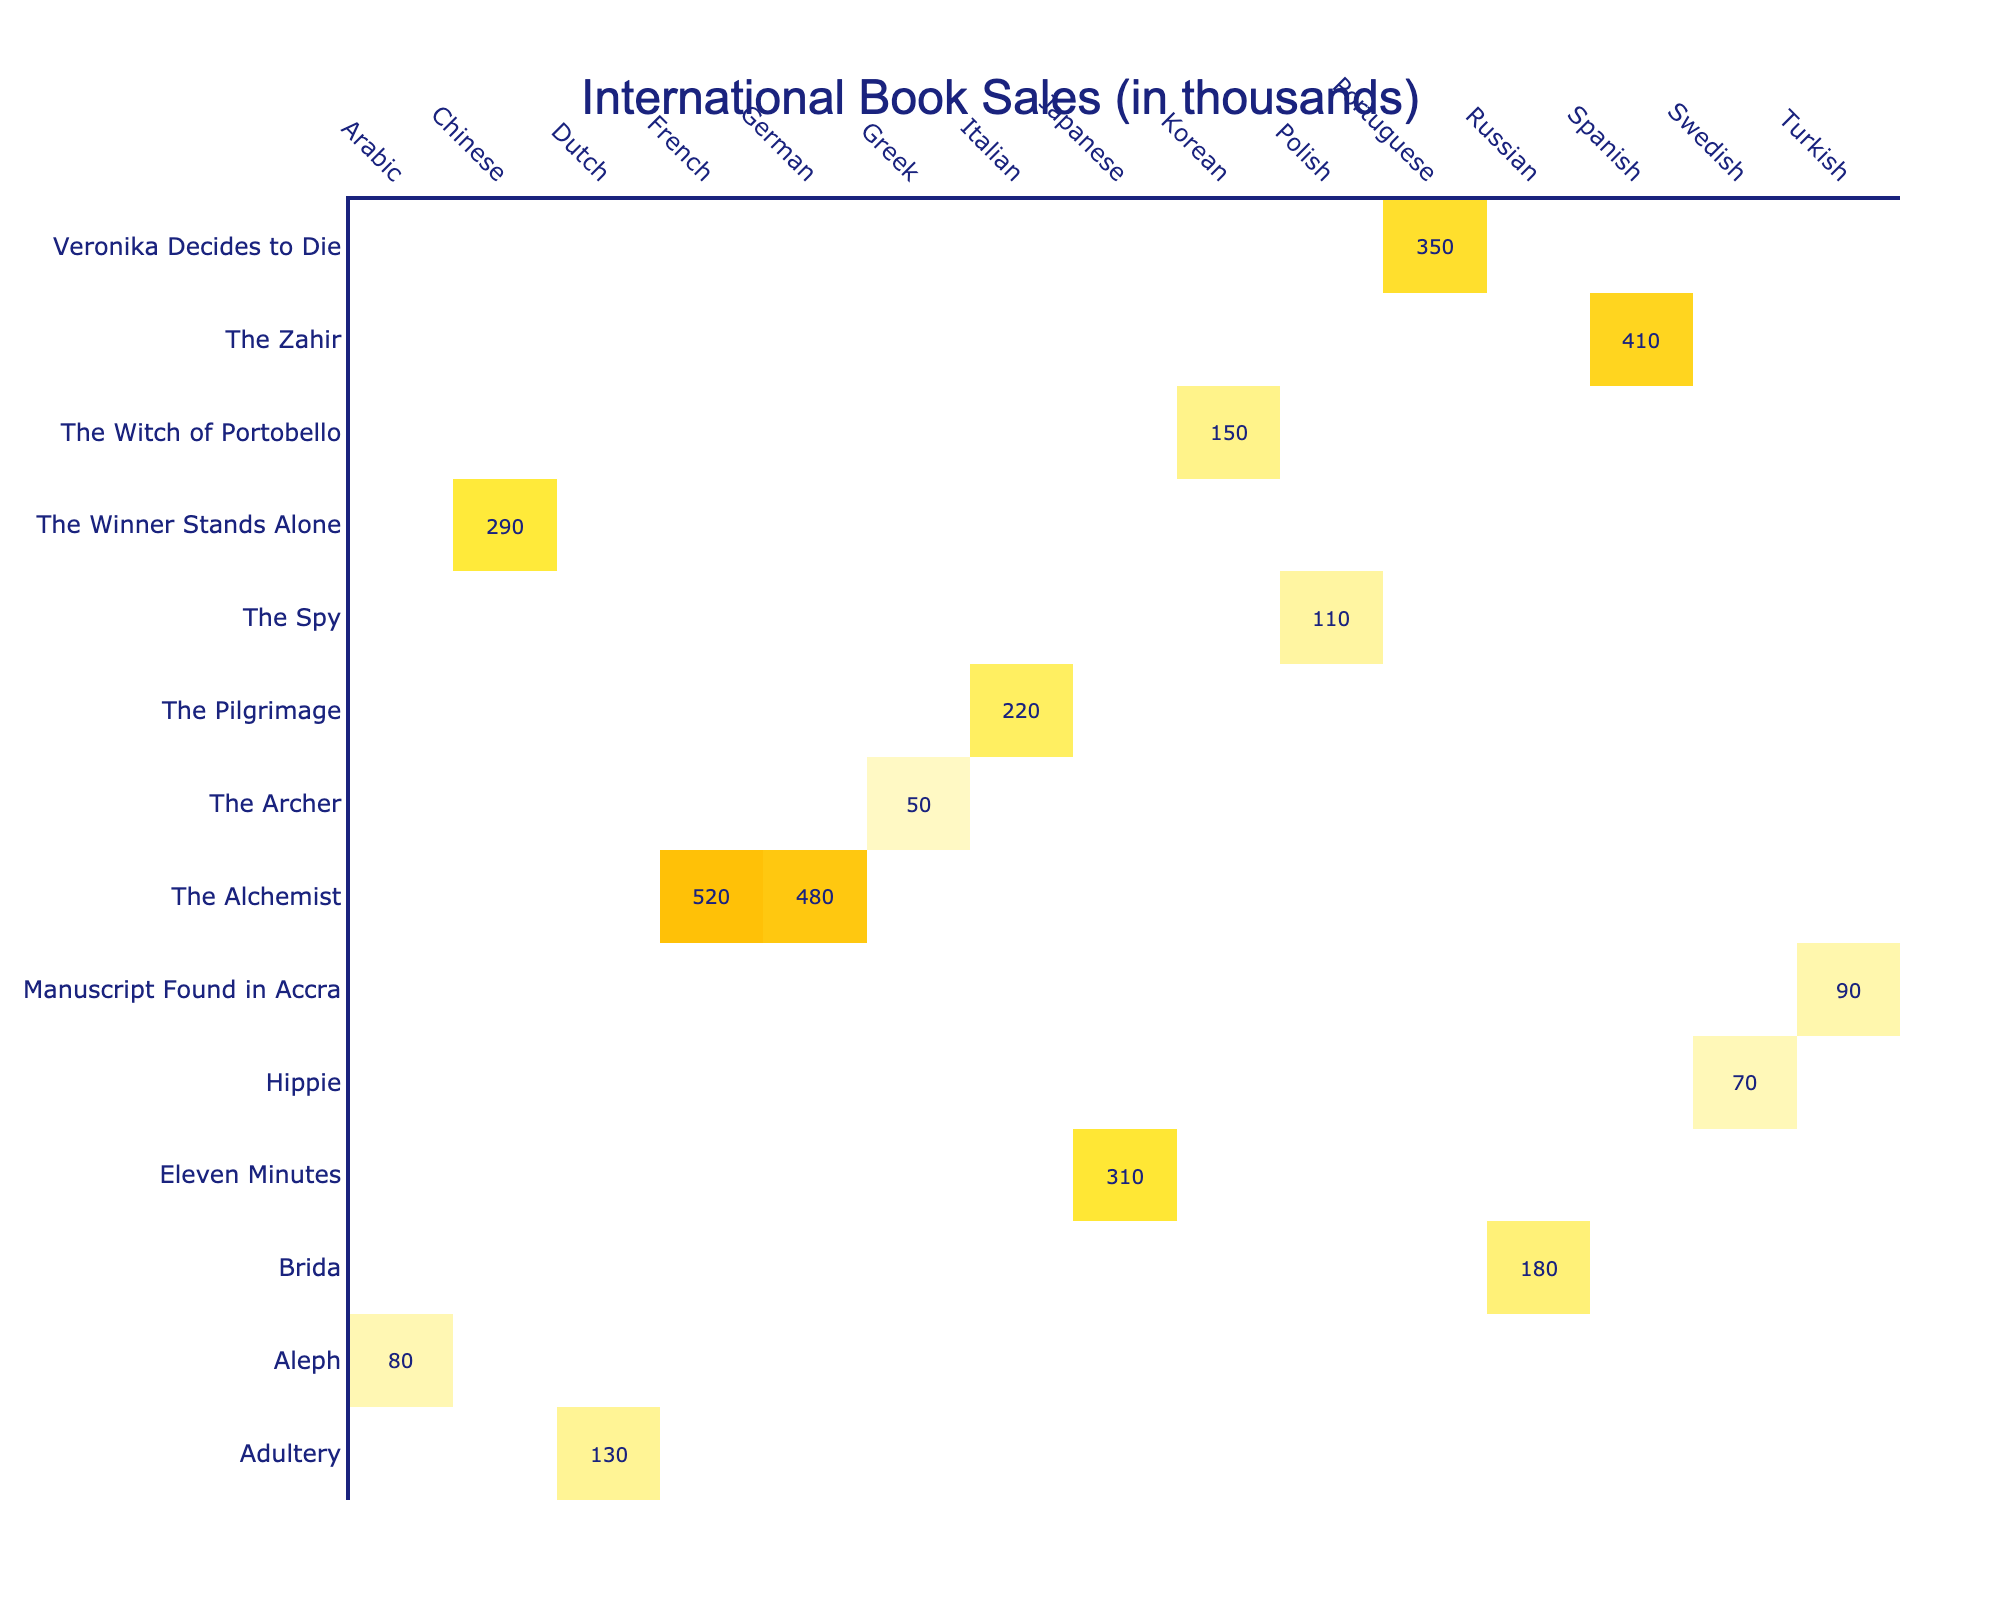What book has the highest sales in France? The table shows that "The Alchemist" has sales of 520 thousands in France, which is the highest among all books listed for that country.
Answer: The Alchemist Which language has the highest sales recorded for "Brida"? From the table, "Brida" has sales of 180 thousands recorded in Russian, and no other language is listed for "Brida," making it the only value available.
Answer: Russian What is the total sales for all the books translated into German? Looking at the table, the only book translated into German is "The Alchemist," which has sales of 480 thousands. Since it is the only entry, the total sales remain 480.
Answer: 480 Did "Eleven Minutes" have higher sales in Japan or "The Spy" in Poland? "Eleven Minutes" has 310 thousands in Japan and "The Spy" has 110 thousands in Poland. Since 310 is greater than 110, "Eleven Minutes" had higher sales.
Answer: Yes What is the average sales of all books translated into Arabic? The only book translated into Arabic is "Aleph," which has sales of 80 thousands. Therefore, the average is simply 80, as there is just one entry.
Answer: 80 Which book had the lowest sales in South Korea? "Hippie" is listed with 70 thousands in Sweden, but it does not apply for South Korea since no value is given for it. The only book listed under South Korea is "The Witch of Portobello," which has 150 thousands, making it the lowest for South Korea.
Answer: The Witch of Portobello What is the difference in sales between the highest and lowest selling book in Spain? In Spain, "The Zahir" is listed with sales of 410 thousands, and since it is the only entry, the lowest is also 410. Thus, the difference is 0, as there's no other book to compare.
Answer: 0 Which country had more sales for "Adultery," Netherlands or Brazil? The table shows that "Adultery" had 130 thousands in the Netherlands and "Veronika Decides to Die" had 350 thousands in Brazil. However, we cannot compare them directly since Adultery is only in the Netherlands.
Answer: No comparison How many different languages were the books translated into? The table lists translations into a total of 12 different languages. Each corresponding to one or more book titles, so each unique language can be counted from the list presented.
Answer: 12 Is there any book that has sales data across more than one language? From the data presented, "The Alchemist" appears in both French and German, making it the only book that has sales listed across multiple languages.
Answer: Yes What is the total sales for books published in 2010? Looking at the table, "The Winner Stands Alone" published in 2010 has sales of 290 thousands. As it is the only book published that year, the total remains 290 thousands.
Answer: 290 